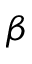<formula> <loc_0><loc_0><loc_500><loc_500>\beta</formula> 